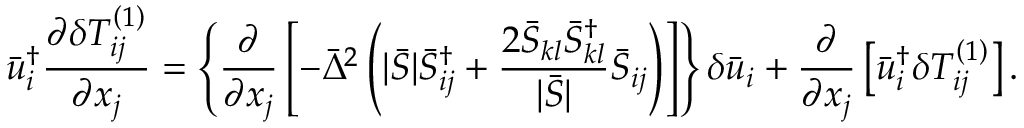<formula> <loc_0><loc_0><loc_500><loc_500>\bar { u } _ { i } ^ { \dag } \frac { { \partial \delta T _ { i j } ^ { \left ( 1 \right ) } } } { { \partial { x _ { j } } } } = \left \{ { \frac { \partial } { { \partial { x _ { j } } } } \left [ { - { { \bar { \Delta } } ^ { 2 } } \left ( { | \bar { S } | \bar { S } _ { i j } ^ { \dag } + \frac { { 2 { { \bar { S } } _ { k l } } \bar { S } _ { k l } ^ { \dag } } } { { | \bar { S } | } } { { \bar { S } } _ { i j } } } \right ) } \right ] } \right \} \delta { { \bar { u } } _ { i } } + \frac { \partial } { { \partial { x _ { j } } } } \left [ { \bar { u } _ { i } ^ { \dag } \delta T _ { i j } ^ { \left ( 1 \right ) } } \right ] .</formula> 